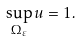Convert formula to latex. <formula><loc_0><loc_0><loc_500><loc_500>\sup _ { \Omega _ { \varepsilon } } u = 1 .</formula> 